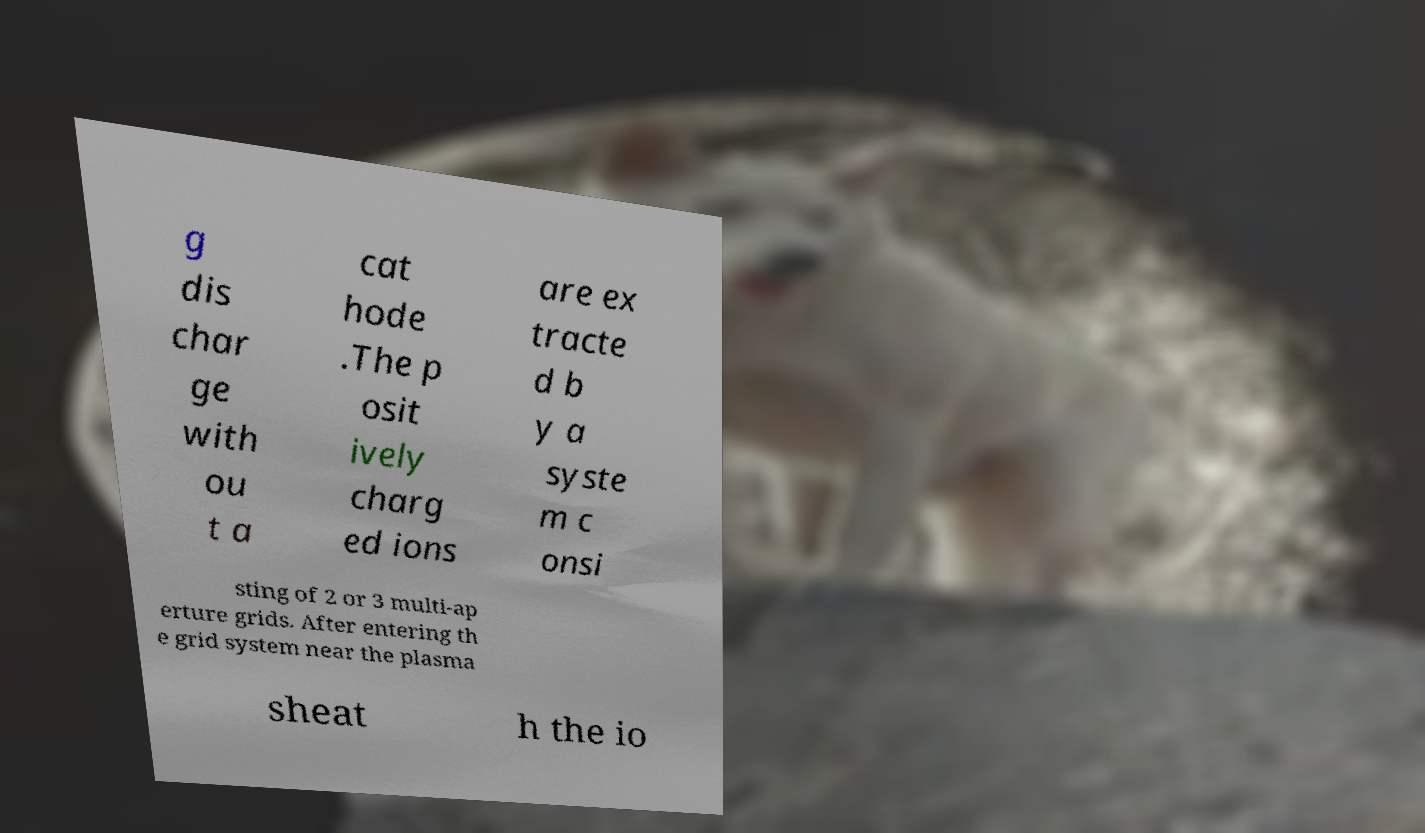Please identify and transcribe the text found in this image. g dis char ge with ou t a cat hode .The p osit ively charg ed ions are ex tracte d b y a syste m c onsi sting of 2 or 3 multi-ap erture grids. After entering th e grid system near the plasma sheat h the io 